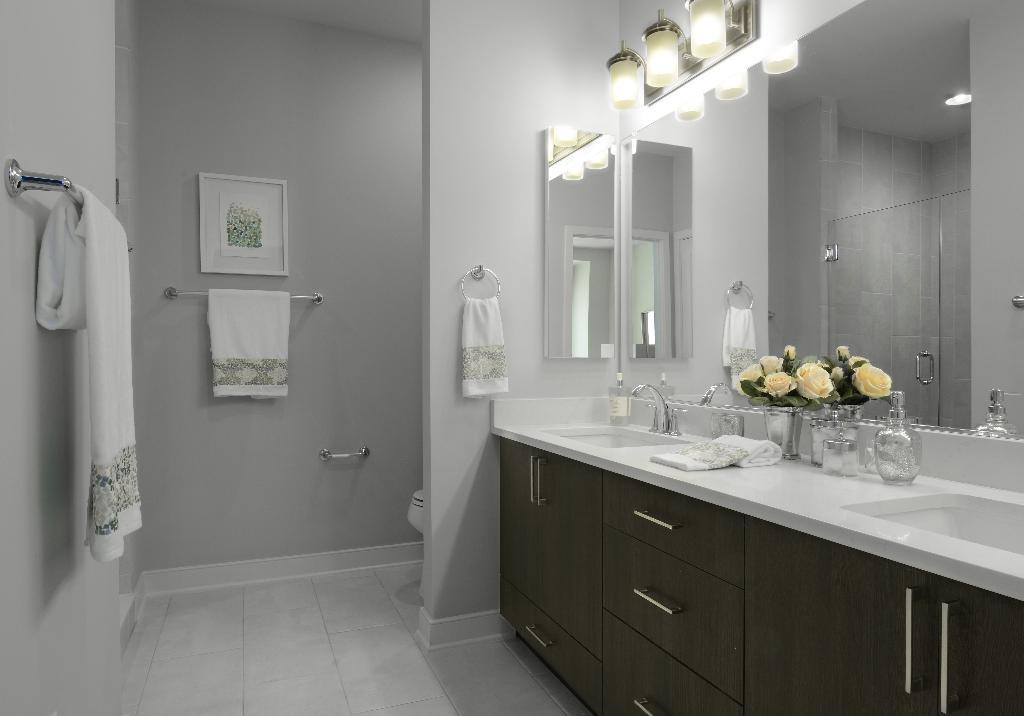In one or two sentences, can you explain what this image depicts? In this image we can see a toilet. There is a mirror in the image. There are towels in the image. There are few objects placed on the surface. There are few lamps attached to a wall. There is a photo frame on the wall. 